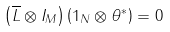Convert formula to latex. <formula><loc_0><loc_0><loc_500><loc_500>\left ( \overline { L } \otimes I _ { M } \right ) \left ( 1 _ { N } \otimes \theta ^ { \ast } \right ) = 0</formula> 